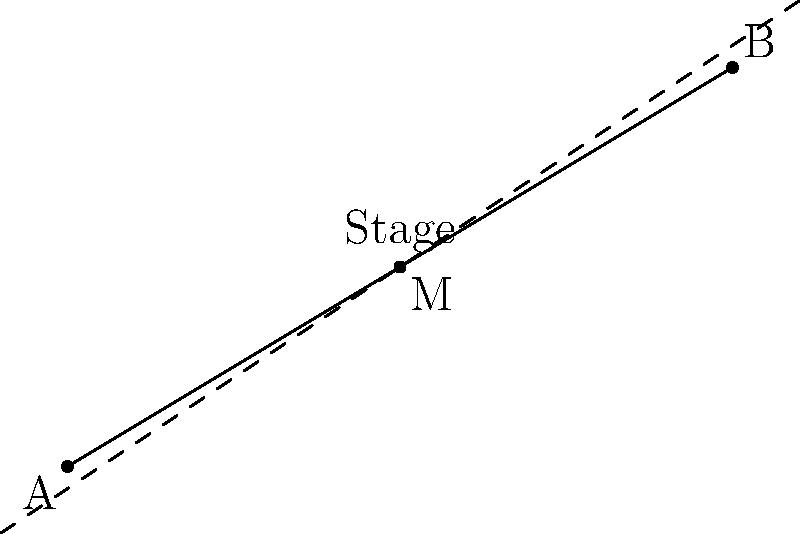As an aspiring actress, you're preparing for a performance at the Théâtre de la Huchette in Paris. The stage manager asks you to determine the center of the stage for optimal positioning. Given that one corner of the stage is at point A(-4, -2) and the opposite corner is at point B(6, 4), find the coordinates of the midpoint M that represents the center of the stage. To find the midpoint M of a line segment AB, we use the midpoint formula:

$$M = (\frac{x_1 + x_2}{2}, \frac{y_1 + y_2}{2})$$

Where $(x_1, y_1)$ are the coordinates of point A and $(x_2, y_2)$ are the coordinates of point B.

Step 1: Identify the coordinates
A: $(-4, -2)$
B: $(6, 4)$

Step 2: Apply the midpoint formula
$$x_M = \frac{x_1 + x_2}{2} = \frac{-4 + 6}{2} = \frac{2}{2} = 1$$
$$y_M = \frac{y_1 + y_2}{2} = \frac{-2 + 4}{2} = \frac{2}{2} = 1$$

Step 3: Combine the results
The midpoint M has coordinates $(1, 1)$.
Answer: $(1, 1)$ 